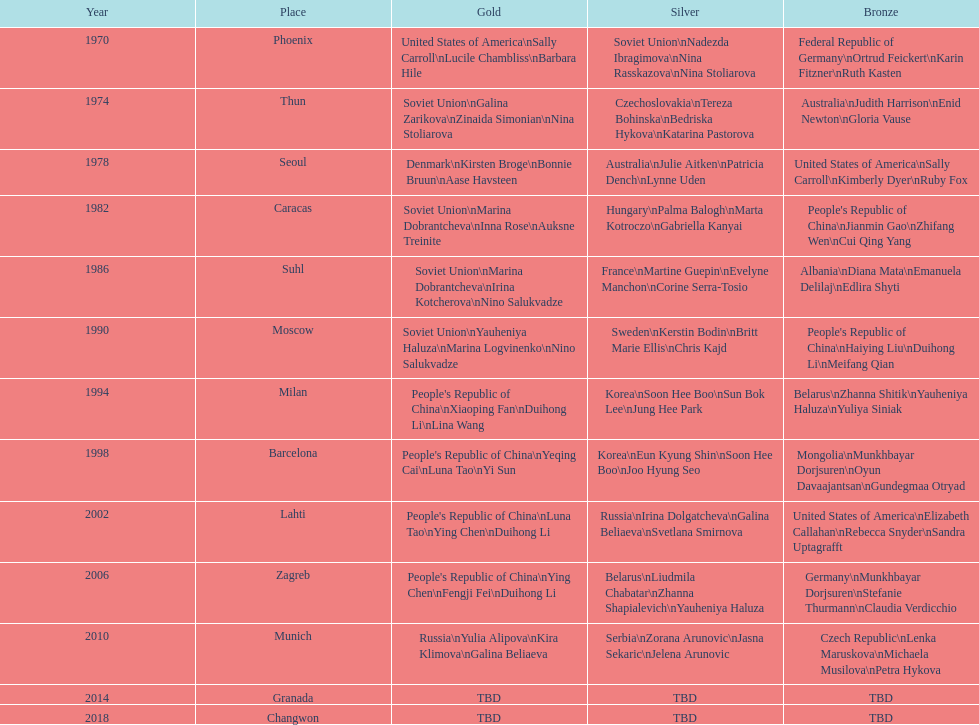What is the total number of bronze victories for germany? 2. 